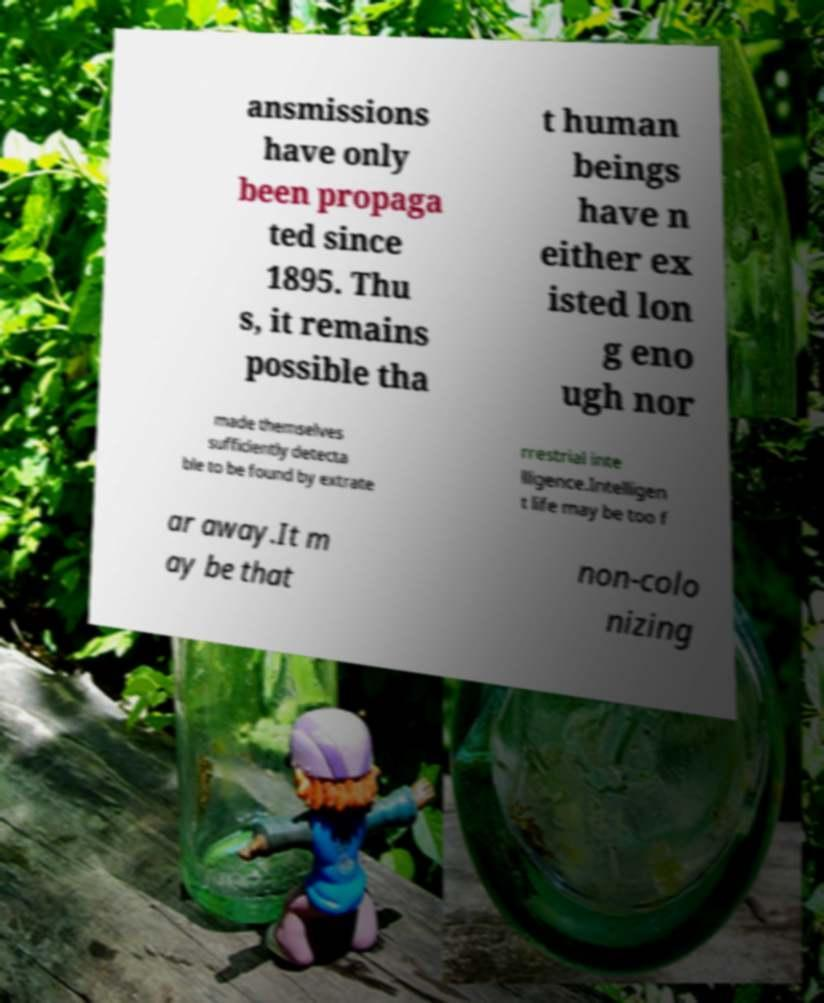Please read and relay the text visible in this image. What does it say? ansmissions have only been propaga ted since 1895. Thu s, it remains possible tha t human beings have n either ex isted lon g eno ugh nor made themselves sufficiently detecta ble to be found by extrate rrestrial inte lligence.Intelligen t life may be too f ar away.It m ay be that non-colo nizing 